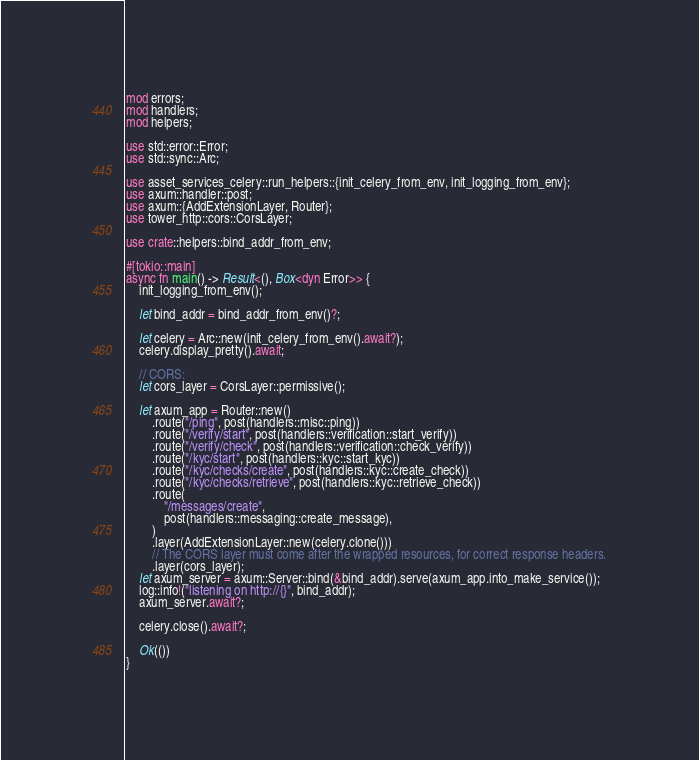<code> <loc_0><loc_0><loc_500><loc_500><_Rust_>mod errors;
mod handlers;
mod helpers;

use std::error::Error;
use std::sync::Arc;

use asset_services_celery::run_helpers::{init_celery_from_env, init_logging_from_env};
use axum::handler::post;
use axum::{AddExtensionLayer, Router};
use tower_http::cors::CorsLayer;

use crate::helpers::bind_addr_from_env;

#[tokio::main]
async fn main() -> Result<(), Box<dyn Error>> {
    init_logging_from_env();

    let bind_addr = bind_addr_from_env()?;

    let celery = Arc::new(init_celery_from_env().await?);
    celery.display_pretty().await;

    // CORS:
    let cors_layer = CorsLayer::permissive();

    let axum_app = Router::new()
        .route("/ping", post(handlers::misc::ping))
        .route("/verify/start", post(handlers::verification::start_verify))
        .route("/verify/check", post(handlers::verification::check_verify))
        .route("/kyc/start", post(handlers::kyc::start_kyc))
        .route("/kyc/checks/create", post(handlers::kyc::create_check))
        .route("/kyc/checks/retrieve", post(handlers::kyc::retrieve_check))
        .route(
            "/messages/create",
            post(handlers::messaging::create_message),
        )
        .layer(AddExtensionLayer::new(celery.clone()))
        // The CORS layer must come after the wrapped resources, for correct response headers.
        .layer(cors_layer);
    let axum_server = axum::Server::bind(&bind_addr).serve(axum_app.into_make_service());
    log::info!("listening on http://{}", bind_addr);
    axum_server.await?;

    celery.close().await?;

    Ok(())
}
</code> 